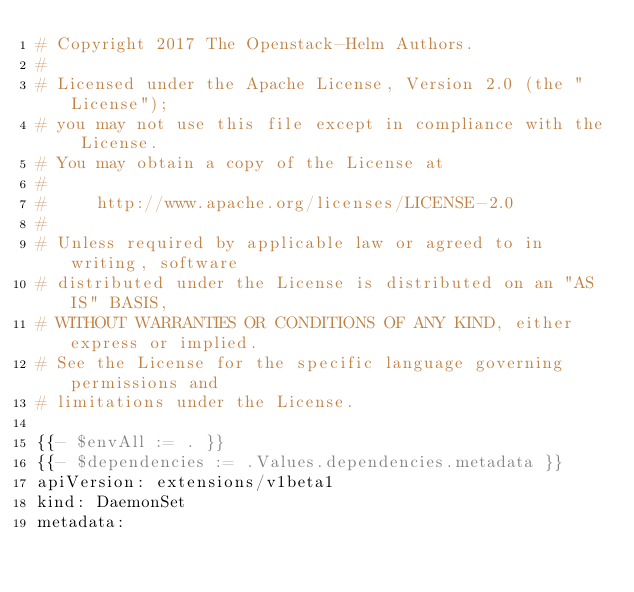Convert code to text. <code><loc_0><loc_0><loc_500><loc_500><_YAML_># Copyright 2017 The Openstack-Helm Authors.
#
# Licensed under the Apache License, Version 2.0 (the "License");
# you may not use this file except in compliance with the License.
# You may obtain a copy of the License at
#
#     http://www.apache.org/licenses/LICENSE-2.0
#
# Unless required by applicable law or agreed to in writing, software
# distributed under the License is distributed on an "AS IS" BASIS,
# WITHOUT WARRANTIES OR CONDITIONS OF ANY KIND, either express or implied.
# See the License for the specific language governing permissions and
# limitations under the License.

{{- $envAll := . }}
{{- $dependencies := .Values.dependencies.metadata }}
apiVersion: extensions/v1beta1
kind: DaemonSet
metadata:</code> 